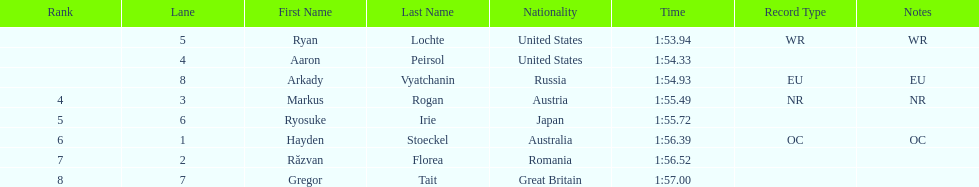Write the full table. {'header': ['Rank', 'Lane', 'First Name', 'Last Name', 'Nationality', 'Time', 'Record Type', 'Notes'], 'rows': [['', '5', 'Ryan', 'Lochte', 'United States', '1:53.94', 'WR', 'WR'], ['', '4', 'Aaron', 'Peirsol', 'United States', '1:54.33', '', ''], ['', '8', 'Arkady', 'Vyatchanin', 'Russia', '1:54.93', 'EU', 'EU'], ['4', '3', 'Markus', 'Rogan', 'Austria', '1:55.49', 'NR', 'NR'], ['5', '6', 'Ryosuke', 'Irie', 'Japan', '1:55.72', '', ''], ['6', '1', 'Hayden', 'Stoeckel', 'Australia', '1:56.39', 'OC', 'OC'], ['7', '2', 'Răzvan', 'Florea', 'Romania', '1:56.52', '', ''], ['8', '7', 'Gregor', 'Tait', 'Great Britain', '1:57.00', '', '']]} Which competitor was the last to place? Gregor Tait. 